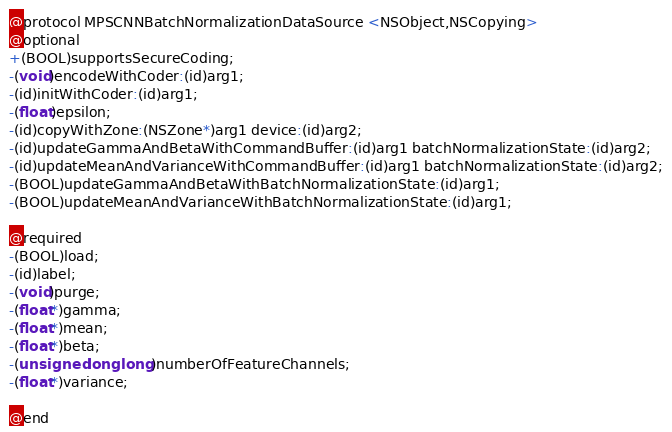Convert code to text. <code><loc_0><loc_0><loc_500><loc_500><_C_>
@protocol MPSCNNBatchNormalizationDataSource <NSObject,NSCopying>
@optional
+(BOOL)supportsSecureCoding;
-(void)encodeWithCoder:(id)arg1;
-(id)initWithCoder:(id)arg1;
-(float)epsilon;
-(id)copyWithZone:(NSZone*)arg1 device:(id)arg2;
-(id)updateGammaAndBetaWithCommandBuffer:(id)arg1 batchNormalizationState:(id)arg2;
-(id)updateMeanAndVarianceWithCommandBuffer:(id)arg1 batchNormalizationState:(id)arg2;
-(BOOL)updateGammaAndBetaWithBatchNormalizationState:(id)arg1;
-(BOOL)updateMeanAndVarianceWithBatchNormalizationState:(id)arg1;

@required
-(BOOL)load;
-(id)label;
-(void)purge;
-(float*)gamma;
-(float*)mean;
-(float*)beta;
-(unsigned long long)numberOfFeatureChannels;
-(float*)variance;

@end

</code> 